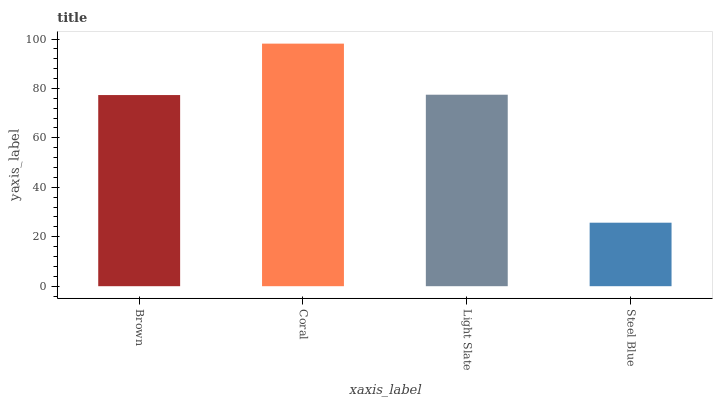Is Steel Blue the minimum?
Answer yes or no. Yes. Is Coral the maximum?
Answer yes or no. Yes. Is Light Slate the minimum?
Answer yes or no. No. Is Light Slate the maximum?
Answer yes or no. No. Is Coral greater than Light Slate?
Answer yes or no. Yes. Is Light Slate less than Coral?
Answer yes or no. Yes. Is Light Slate greater than Coral?
Answer yes or no. No. Is Coral less than Light Slate?
Answer yes or no. No. Is Light Slate the high median?
Answer yes or no. Yes. Is Brown the low median?
Answer yes or no. Yes. Is Brown the high median?
Answer yes or no. No. Is Coral the low median?
Answer yes or no. No. 